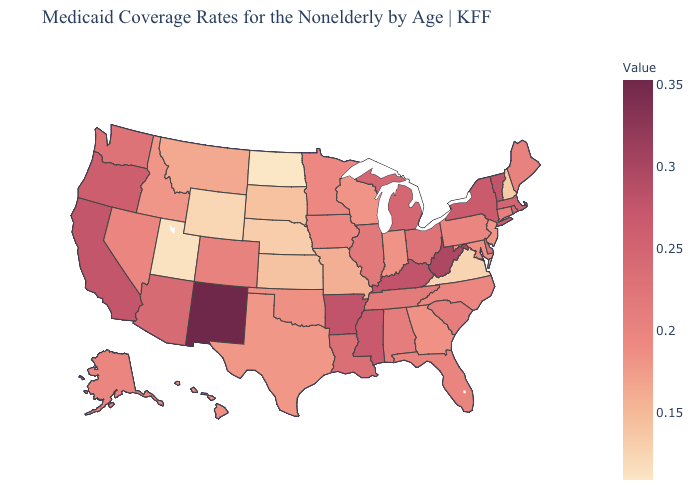Among the states that border Virginia , which have the lowest value?
Quick response, please. Maryland. Does Tennessee have the highest value in the USA?
Write a very short answer. No. Which states have the lowest value in the MidWest?
Be succinct. North Dakota. Does New Mexico have the highest value in the USA?
Give a very brief answer. Yes. Does Michigan have the highest value in the MidWest?
Write a very short answer. Yes. 